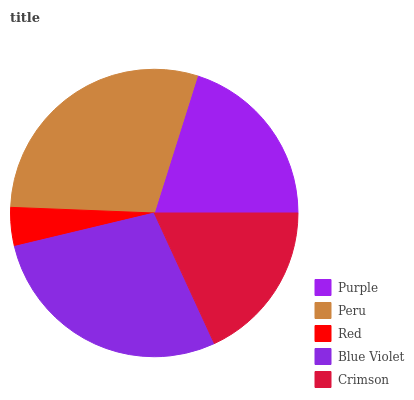Is Red the minimum?
Answer yes or no. Yes. Is Peru the maximum?
Answer yes or no. Yes. Is Peru the minimum?
Answer yes or no. No. Is Red the maximum?
Answer yes or no. No. Is Peru greater than Red?
Answer yes or no. Yes. Is Red less than Peru?
Answer yes or no. Yes. Is Red greater than Peru?
Answer yes or no. No. Is Peru less than Red?
Answer yes or no. No. Is Purple the high median?
Answer yes or no. Yes. Is Purple the low median?
Answer yes or no. Yes. Is Blue Violet the high median?
Answer yes or no. No. Is Blue Violet the low median?
Answer yes or no. No. 